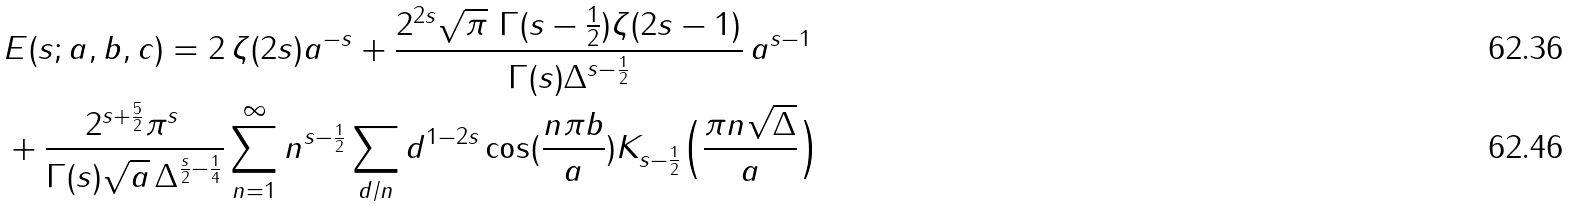Convert formula to latex. <formula><loc_0><loc_0><loc_500><loc_500>& E ( s ; a , b , c ) = 2 { \, } \zeta ( 2 s ) a ^ { - s } + \frac { 2 ^ { 2 s } \sqrt { \pi } { \, } { \, } \Gamma ( s - \frac { 1 } { 2 } ) \zeta ( 2 s - 1 ) } { \Gamma ( s ) \Delta ^ { s - \frac { 1 } { 2 } } } { \, } a ^ { s - 1 } \\ & + \frac { 2 ^ { s + \frac { 5 } { 2 } } \pi ^ { s } { \, } } { \Gamma ( s ) \sqrt { a } { \, } \Delta ^ { \frac { s } { 2 } - \frac { 1 } { 4 } } } \sum _ { n = 1 } ^ { \infty } n ^ { s - \frac { 1 } { 2 } } \sum _ { d / n } d ^ { 1 - 2 s } \cos ( \frac { n \pi b } { a } ) K _ { s - \frac { 1 } { 2 } } \Big { ( } \frac { \pi n \sqrt { \Delta } } { a } \Big { ) }</formula> 